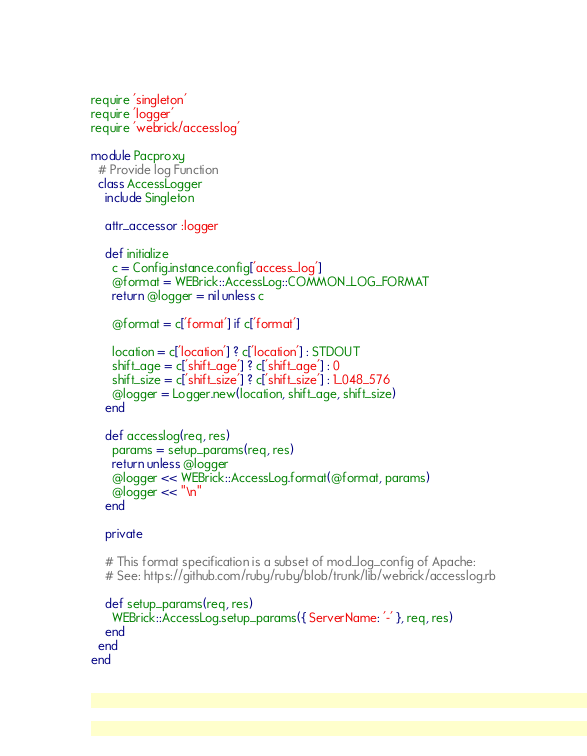<code> <loc_0><loc_0><loc_500><loc_500><_Ruby_>require 'singleton'
require 'logger'
require 'webrick/accesslog'

module Pacproxy
  # Provide log Function
  class AccessLogger
    include Singleton

    attr_accessor :logger

    def initialize
      c = Config.instance.config['access_log']
      @format = WEBrick::AccessLog::COMMON_LOG_FORMAT
      return @logger = nil unless c

      @format = c['format'] if c['format']

      location = c['location'] ? c['location'] : STDOUT
      shift_age = c['shift_age'] ? c['shift_age'] : 0
      shift_size = c['shift_size'] ? c['shift_size'] : 1_048_576
      @logger = Logger.new(location, shift_age, shift_size)
    end

    def accesslog(req, res)
      params = setup_params(req, res)
      return unless @logger
      @logger << WEBrick::AccessLog.format(@format, params)
      @logger << "\n"
    end

    private

    # This format specification is a subset of mod_log_config of Apache:
    # See: https://github.com/ruby/ruby/blob/trunk/lib/webrick/accesslog.rb

    def setup_params(req, res)
      WEBrick::AccessLog.setup_params({ ServerName: '-' }, req, res)
    end
  end
end
</code> 